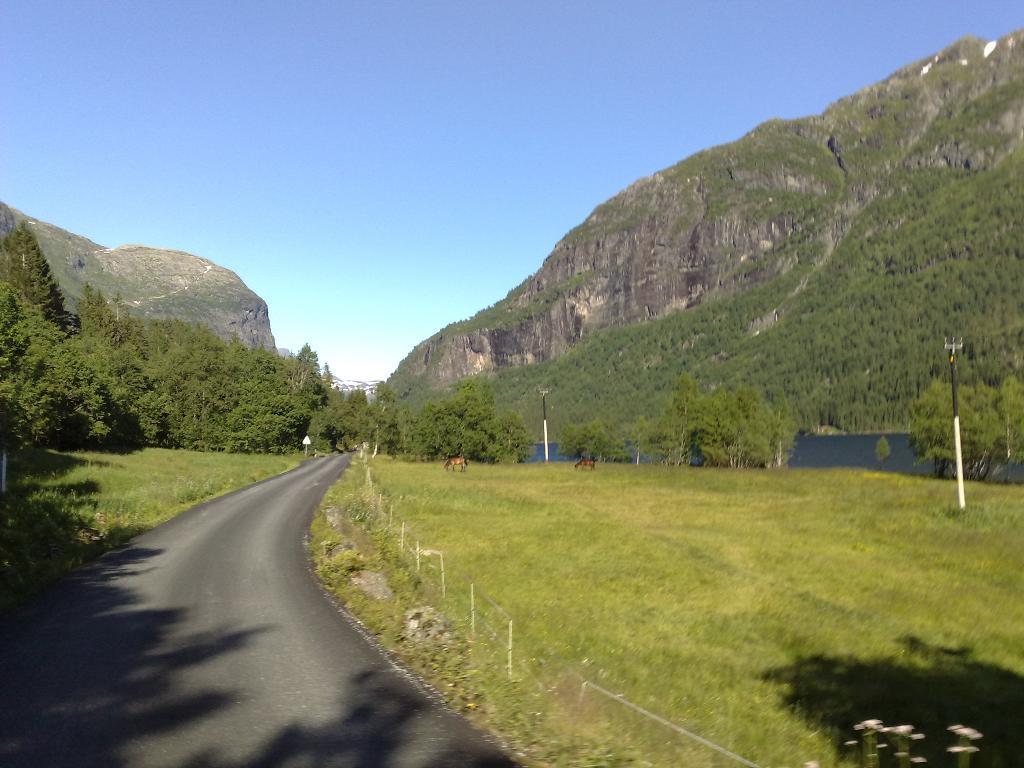Describe this image in one or two sentences. On the left side, there are shadows of the trees on a road. On the right side, there is grass and a fence. In the background, there are poles, animals, grass, trees, water, mountains, buildings and there are clouds in the sky. 